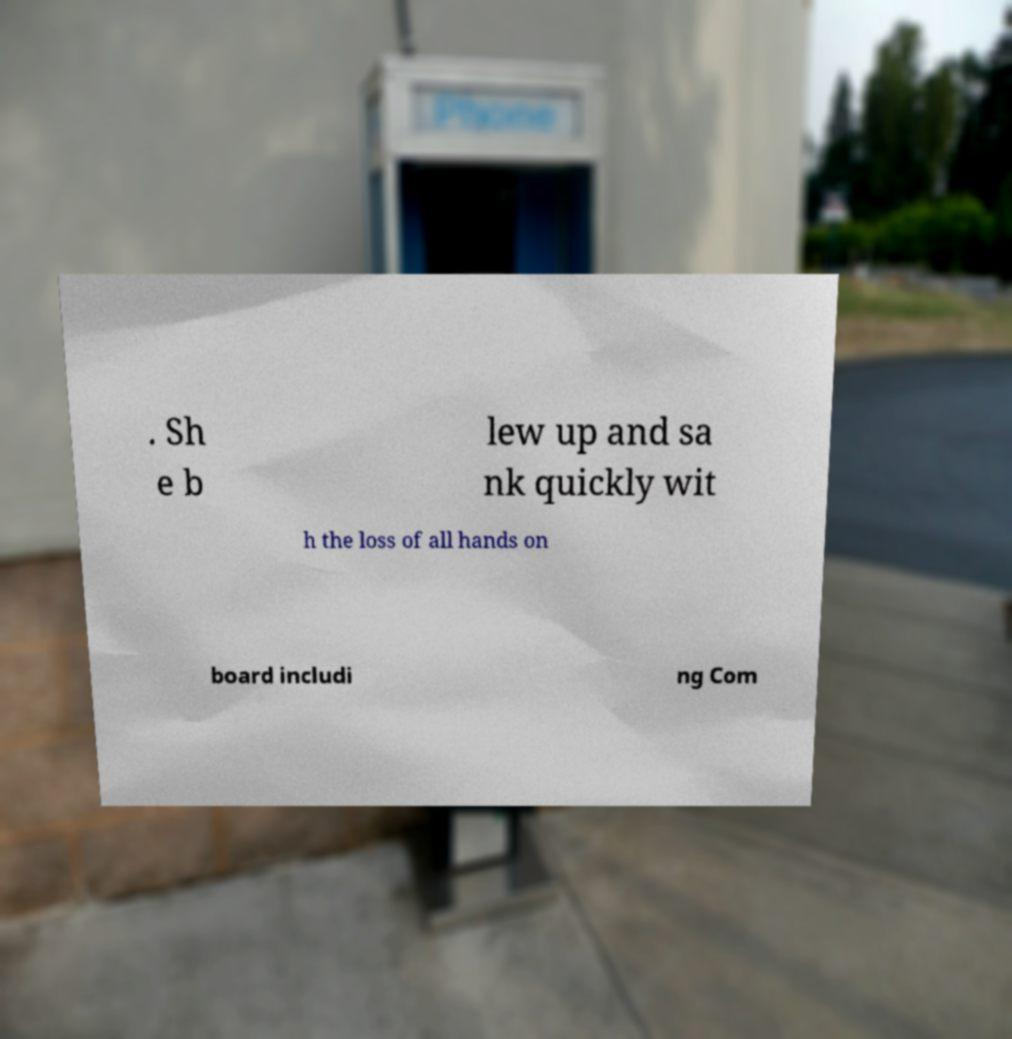For documentation purposes, I need the text within this image transcribed. Could you provide that? . Sh e b lew up and sa nk quickly wit h the loss of all hands on board includi ng Com 